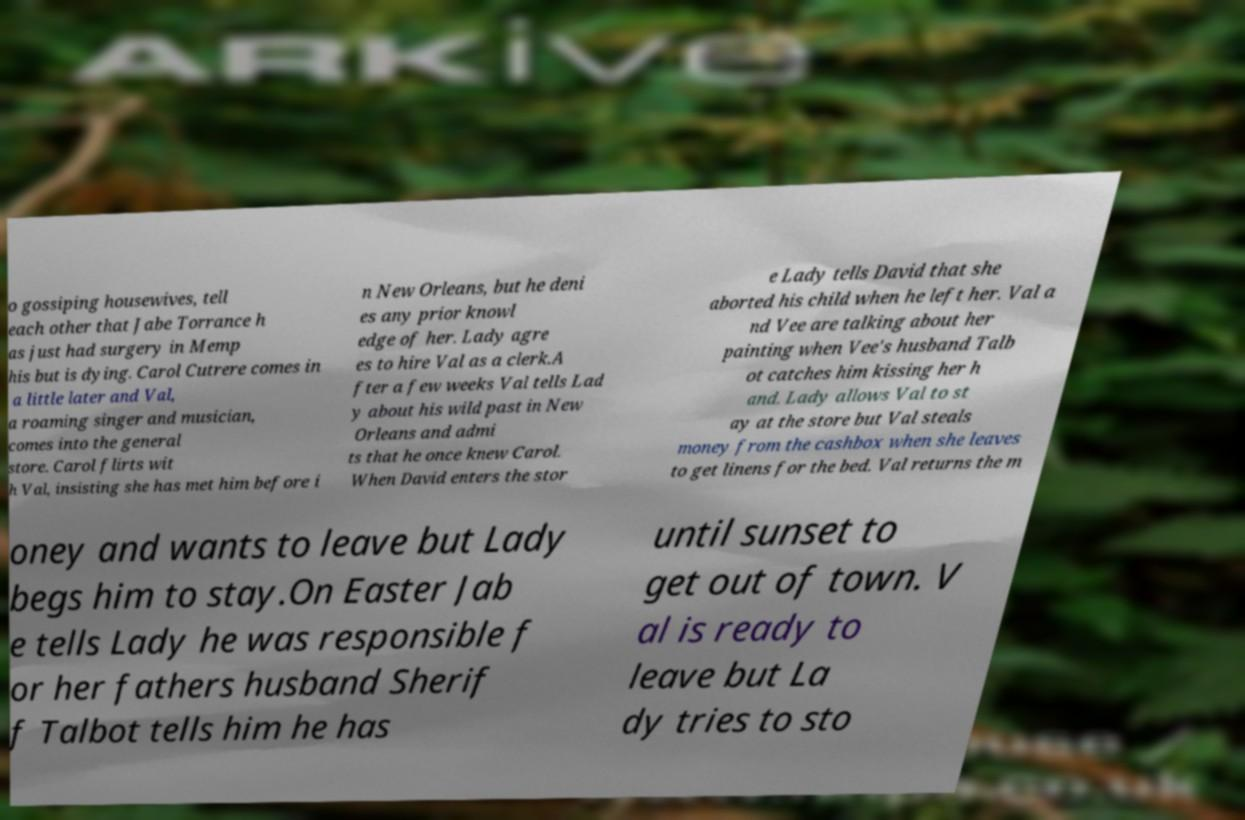Can you read and provide the text displayed in the image?This photo seems to have some interesting text. Can you extract and type it out for me? o gossiping housewives, tell each other that Jabe Torrance h as just had surgery in Memp his but is dying. Carol Cutrere comes in a little later and Val, a roaming singer and musician, comes into the general store. Carol flirts wit h Val, insisting she has met him before i n New Orleans, but he deni es any prior knowl edge of her. Lady agre es to hire Val as a clerk.A fter a few weeks Val tells Lad y about his wild past in New Orleans and admi ts that he once knew Carol. When David enters the stor e Lady tells David that she aborted his child when he left her. Val a nd Vee are talking about her painting when Vee's husband Talb ot catches him kissing her h and. Lady allows Val to st ay at the store but Val steals money from the cashbox when she leaves to get linens for the bed. Val returns the m oney and wants to leave but Lady begs him to stay.On Easter Jab e tells Lady he was responsible f or her fathers husband Sherif f Talbot tells him he has until sunset to get out of town. V al is ready to leave but La dy tries to sto 